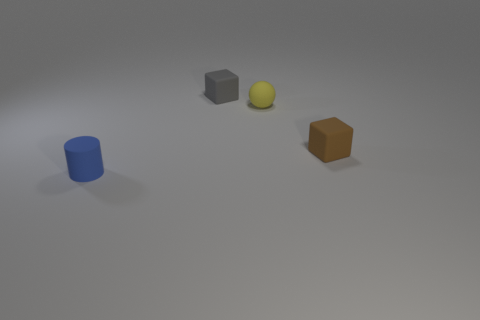How many things are either matte things behind the brown block or brown objects?
Keep it short and to the point. 3. What number of other objects are there of the same shape as the gray thing?
Your answer should be compact. 1. Are there more blue objects that are in front of the gray cube than large spheres?
Offer a terse response. Yes. There is another thing that is the same shape as the brown thing; what is its size?
Provide a short and direct response. Small. The brown matte object has what shape?
Give a very brief answer. Cube. The brown thing that is the same size as the yellow sphere is what shape?
Your answer should be very brief. Cube. Is there any other thing of the same color as the rubber ball?
Your answer should be very brief. No. Does the small blue rubber object have the same shape as the tiny thing to the right of the tiny yellow ball?
Provide a short and direct response. No. Are there fewer matte things to the left of the blue thing than small brown rubber things?
Offer a very short reply. Yes. How many yellow matte objects have the same size as the brown matte thing?
Give a very brief answer. 1. 